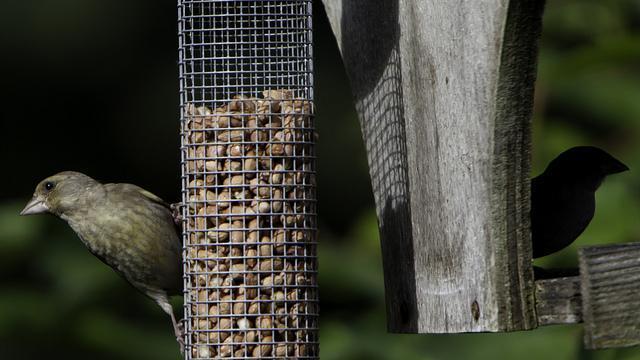How many birds are there?
Give a very brief answer. 2. 